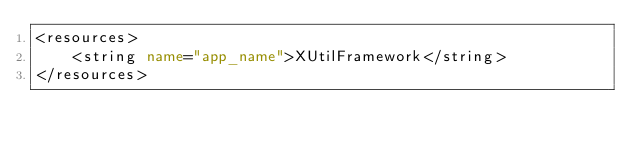Convert code to text. <code><loc_0><loc_0><loc_500><loc_500><_XML_><resources>
    <string name="app_name">XUtilFramework</string>
</resources>
</code> 